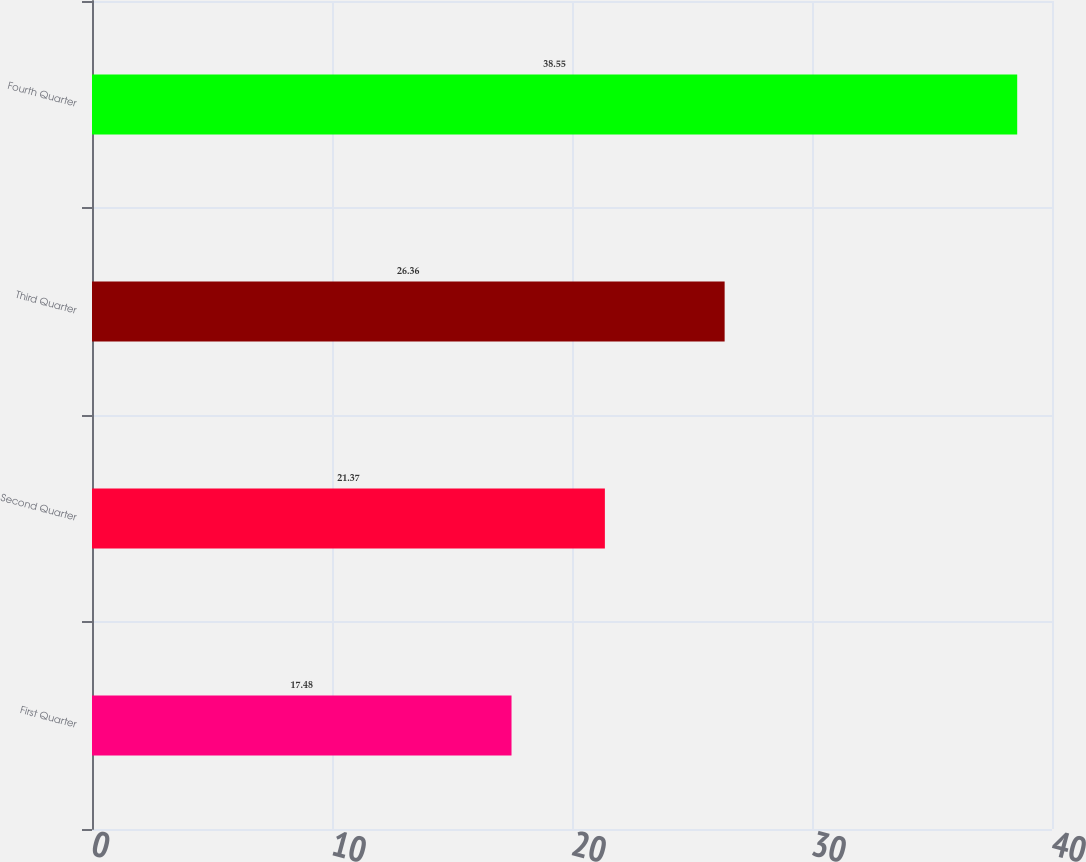<chart> <loc_0><loc_0><loc_500><loc_500><bar_chart><fcel>First Quarter<fcel>Second Quarter<fcel>Third Quarter<fcel>Fourth Quarter<nl><fcel>17.48<fcel>21.37<fcel>26.36<fcel>38.55<nl></chart> 